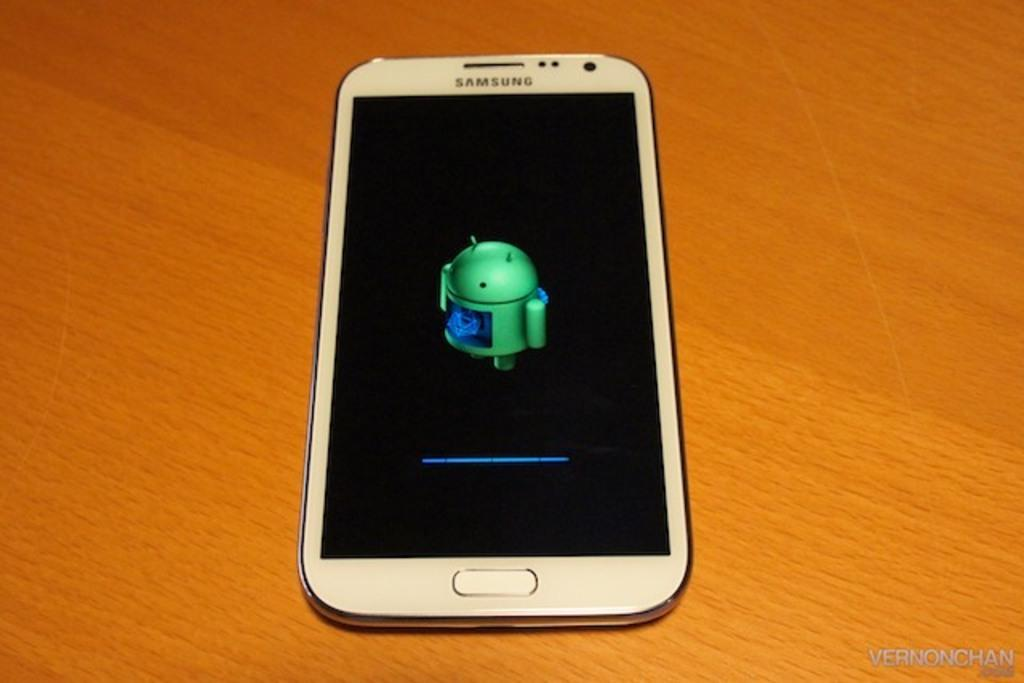<image>
Describe the image concisely. a Samsung phone that is on the table 